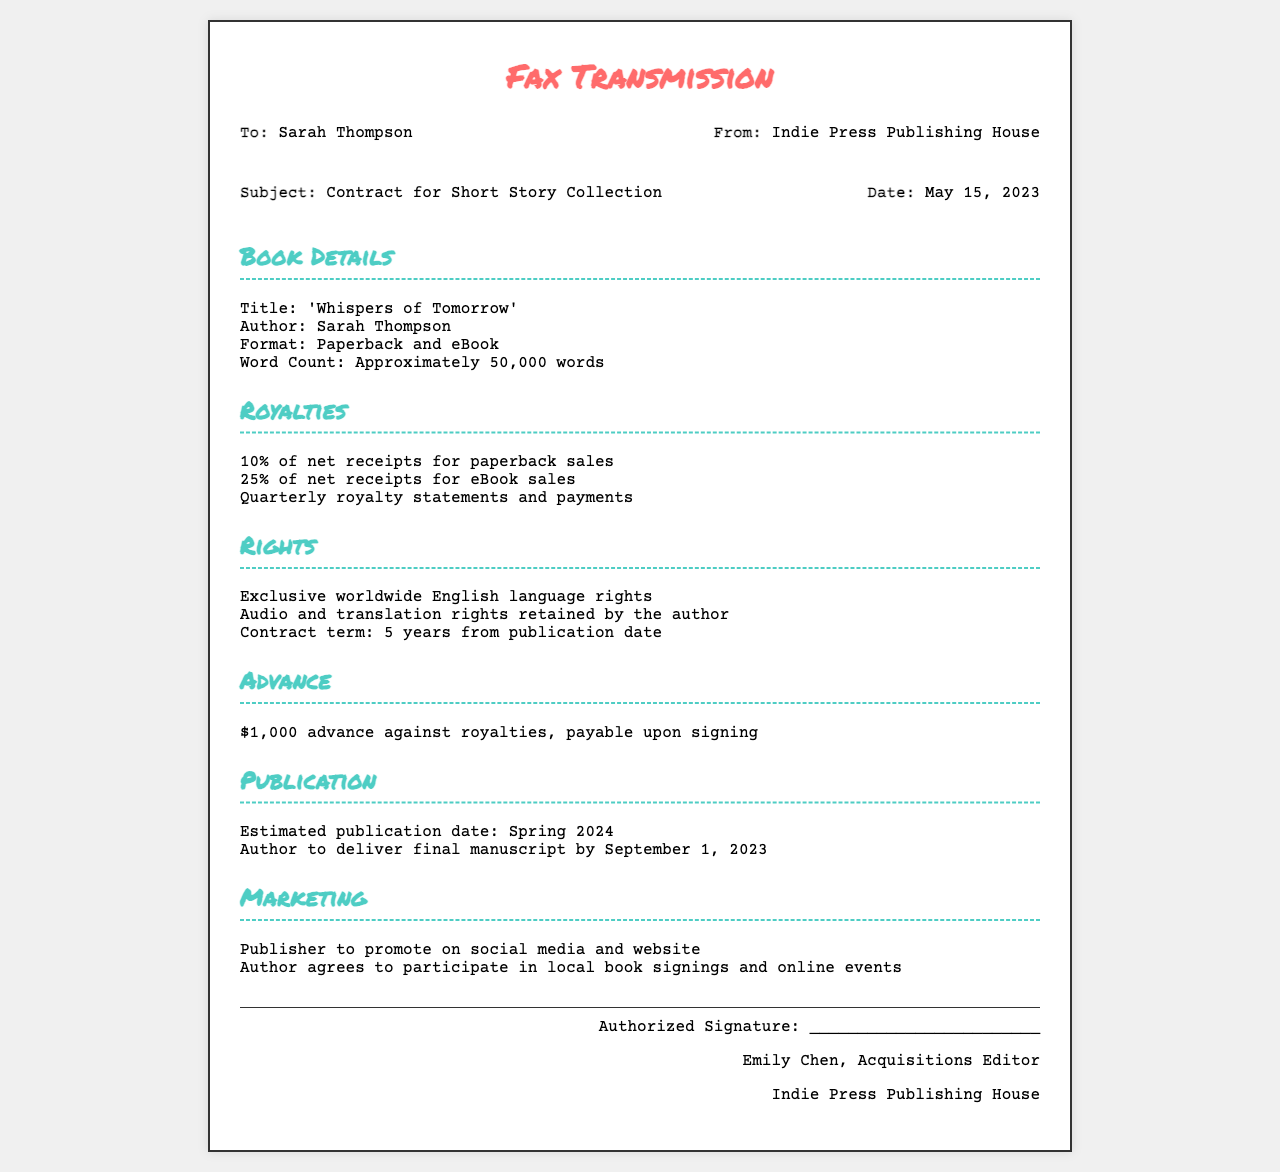What is the title of the book? The title is clearly stated in the document under "Book Details."
Answer: 'Whispers of Tomorrow' What is the author's name? The author's name is found in the "Book Details" section.
Answer: Sarah Thompson What percentage of net receipts does the author receive for eBook sales? This information is provided under the "Royalties" section, detailing the percentage for eBook sales.
Answer: 25% What is the advance amount mentioned in the contract? The advance amount is specified in the "Advance" section of the document.
Answer: $1,000 When is the estimated publication date? The estimated publication date is mentioned under the "Publication" section.
Answer: Spring 2024 How long is the contract term? The contract term is stated in the "Rights" section.
Answer: 5 years What rights does the author retain? The rights retained by the author are outlined in the "Rights" section.
Answer: Audio and translation rights Who is the authorized signer for the contract? The authorized signer's name is provided in the footer of the document.
Answer: Emily Chen What marketing activities is the author expected to participate in? The expected marketing activities are detailed under the "Marketing" section.
Answer: Local book signings and online events 